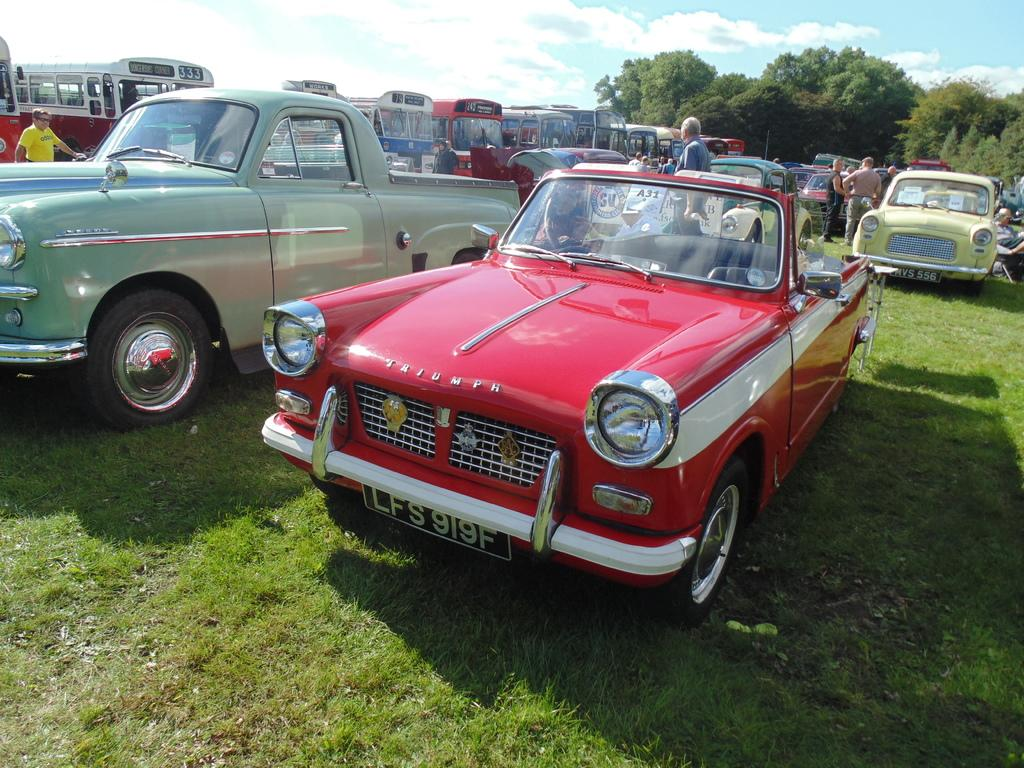What types of objects can be seen in the image? There are vehicles and people in the image. Where are the vehicles and people located? The vehicles and people are on the ground. What can be seen in the background of the image? There are trees and the sky visible in the background of the image. What type of library can be seen in the image? There is no library present in the image; it features vehicles and people on the ground with trees and the sky in the background. 